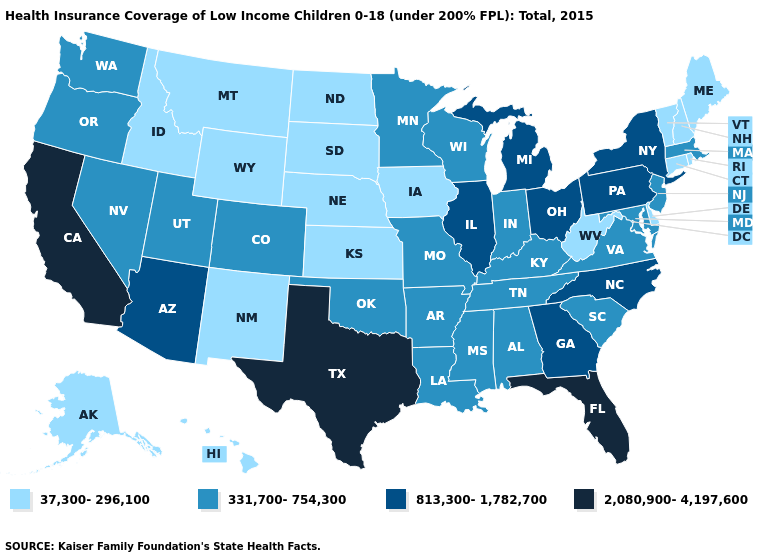What is the lowest value in the Northeast?
Quick response, please. 37,300-296,100. Name the states that have a value in the range 331,700-754,300?
Answer briefly. Alabama, Arkansas, Colorado, Indiana, Kentucky, Louisiana, Maryland, Massachusetts, Minnesota, Mississippi, Missouri, Nevada, New Jersey, Oklahoma, Oregon, South Carolina, Tennessee, Utah, Virginia, Washington, Wisconsin. What is the value of New Jersey?
Keep it brief. 331,700-754,300. Name the states that have a value in the range 331,700-754,300?
Give a very brief answer. Alabama, Arkansas, Colorado, Indiana, Kentucky, Louisiana, Maryland, Massachusetts, Minnesota, Mississippi, Missouri, Nevada, New Jersey, Oklahoma, Oregon, South Carolina, Tennessee, Utah, Virginia, Washington, Wisconsin. Does Mississippi have the highest value in the South?
Concise answer only. No. What is the value of Kentucky?
Write a very short answer. 331,700-754,300. What is the highest value in the USA?
Short answer required. 2,080,900-4,197,600. Name the states that have a value in the range 37,300-296,100?
Give a very brief answer. Alaska, Connecticut, Delaware, Hawaii, Idaho, Iowa, Kansas, Maine, Montana, Nebraska, New Hampshire, New Mexico, North Dakota, Rhode Island, South Dakota, Vermont, West Virginia, Wyoming. What is the lowest value in states that border Nebraska?
Be succinct. 37,300-296,100. What is the value of Nebraska?
Quick response, please. 37,300-296,100. What is the highest value in states that border Minnesota?
Answer briefly. 331,700-754,300. Does Ohio have the lowest value in the MidWest?
Be succinct. No. Name the states that have a value in the range 813,300-1,782,700?
Answer briefly. Arizona, Georgia, Illinois, Michigan, New York, North Carolina, Ohio, Pennsylvania. Among the states that border New Jersey , which have the lowest value?
Keep it brief. Delaware. 